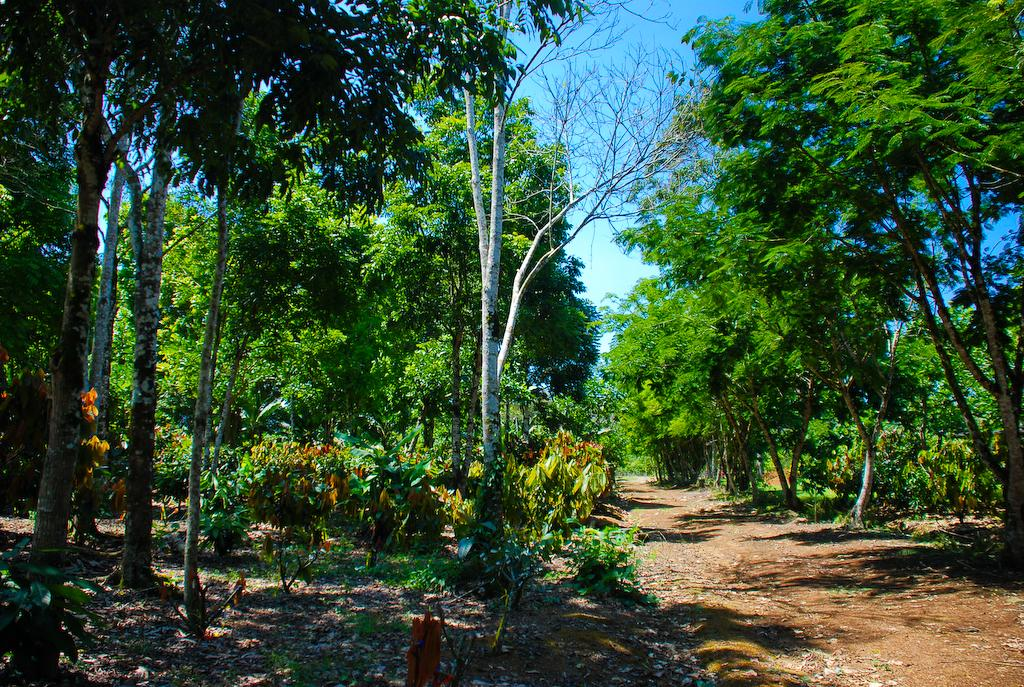What type of vegetation can be seen in the image? There are trees in the image. What is located at the bottom side of the image? There is a path at the bottom side of the image. How many chickens can be seen running along the path in the image? There are no chickens present in the image; it only features trees and a path. Is there a group of rats visible on the path in the image? There are no rats present in the image; it only features trees and a path. 